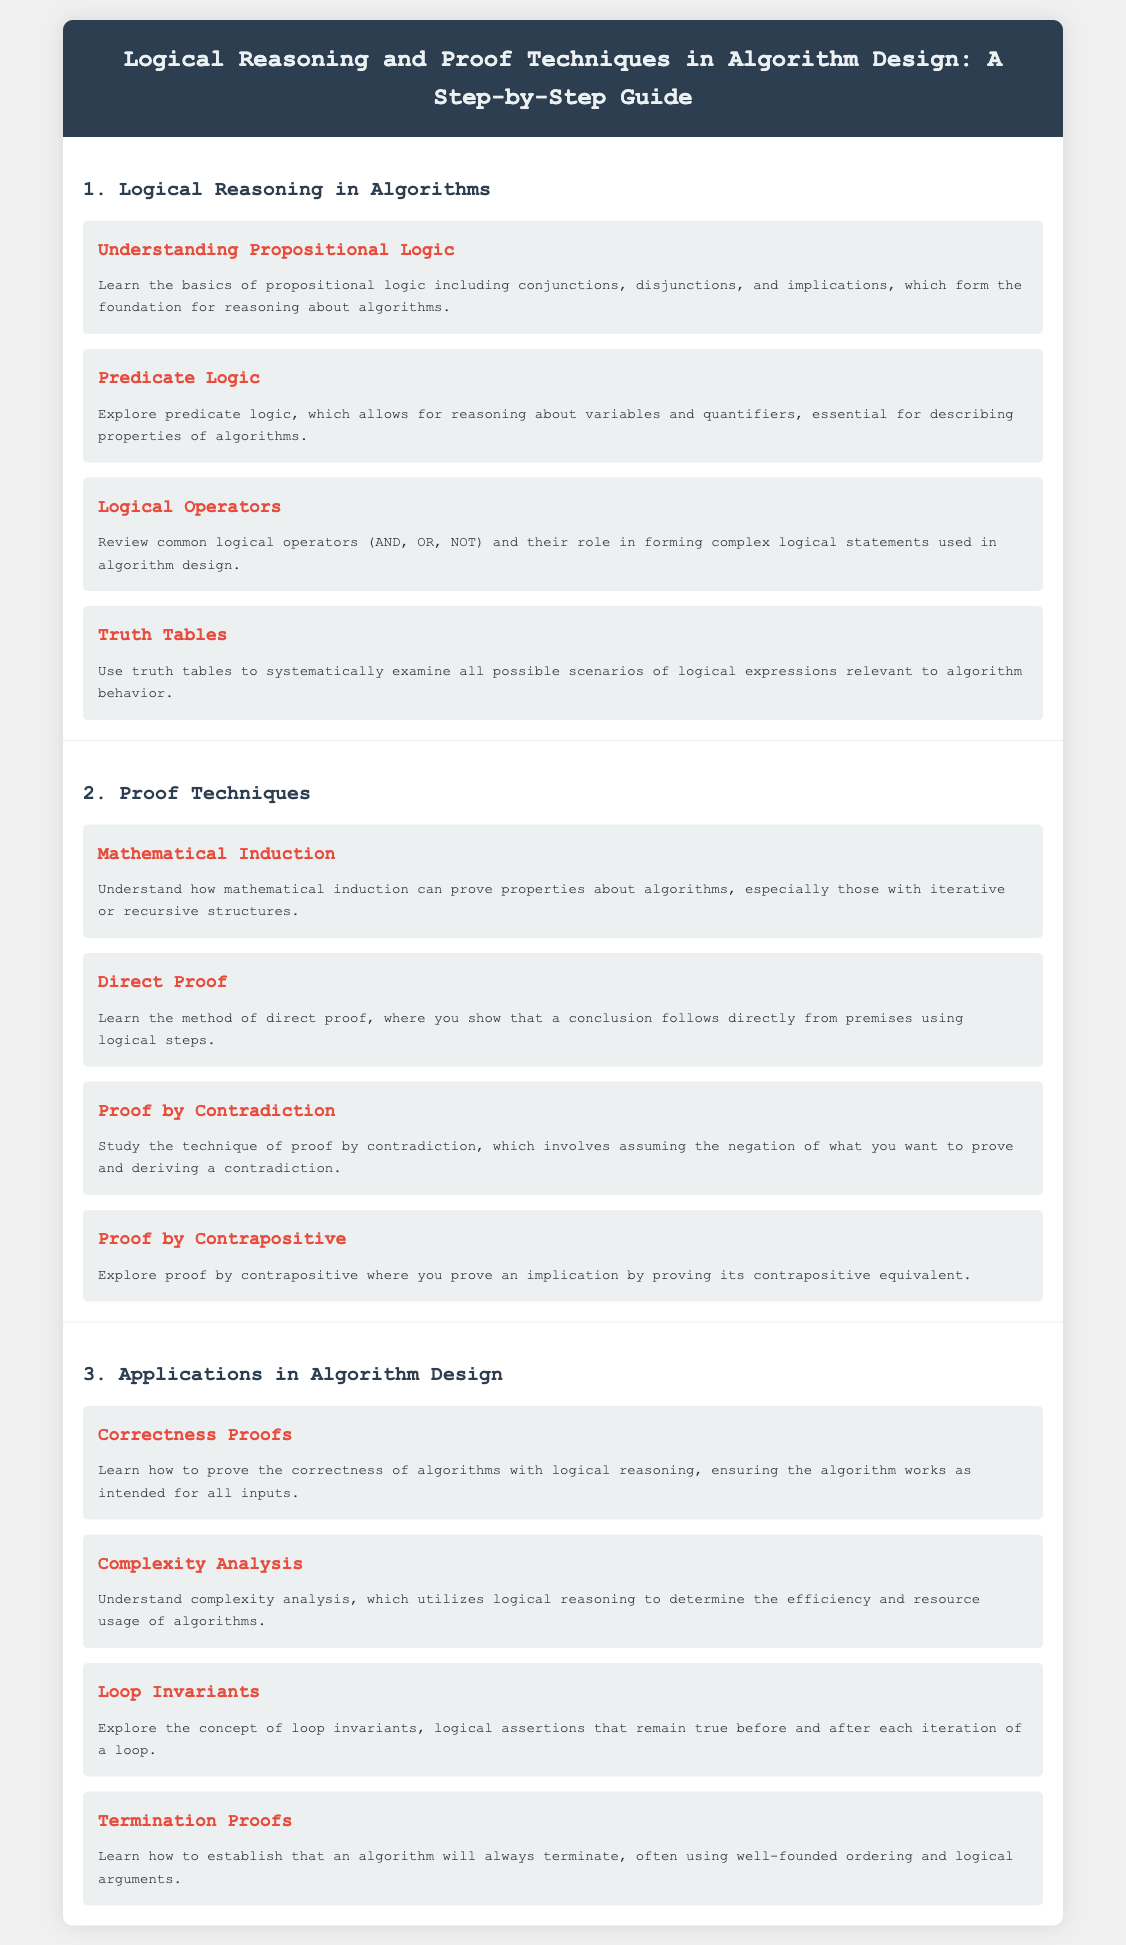What is the title of the document? The title is the main heading of the document, which summarizes its content.
Answer: Logical Reasoning and Proof Techniques in Algorithm Design: A Step-by-Step Guide How many sections are in the document? The document is divided into three main sections, which can be identified in the outline of the content.
Answer: 3 What proof technique is used to prove properties about algorithms with iterative structures? This technique is specifically mentioned in the context of algorithm properties that involve sequences.
Answer: Mathematical Induction What logical operator is NOT mentioned in the document? The document highlights common logical operators but does not mention a specific one as per the given context.
Answer: None What is the role of loop invariants in algorithm design? Loop invariants play an essential role in verifying the correctness of iterative processes within algorithms.
Answer: Logical assertions Which proof technique assumes the negation of what you want to prove? This technique involves a specific logical reasoning approach that leads to a contradiction from the opposite assumption.
Answer: Proof by Contradiction What does complexity analysis utilize for determining efficiency? Complexity analysis employs logical reasoning as a key component to make evaluations regarding algorithms.
Answer: Logical reasoning What is established through termination proofs? This validation process confirms a crucial aspect of algorithm behavior relevant to its functionality.
Answer: Algorithm will always terminate 